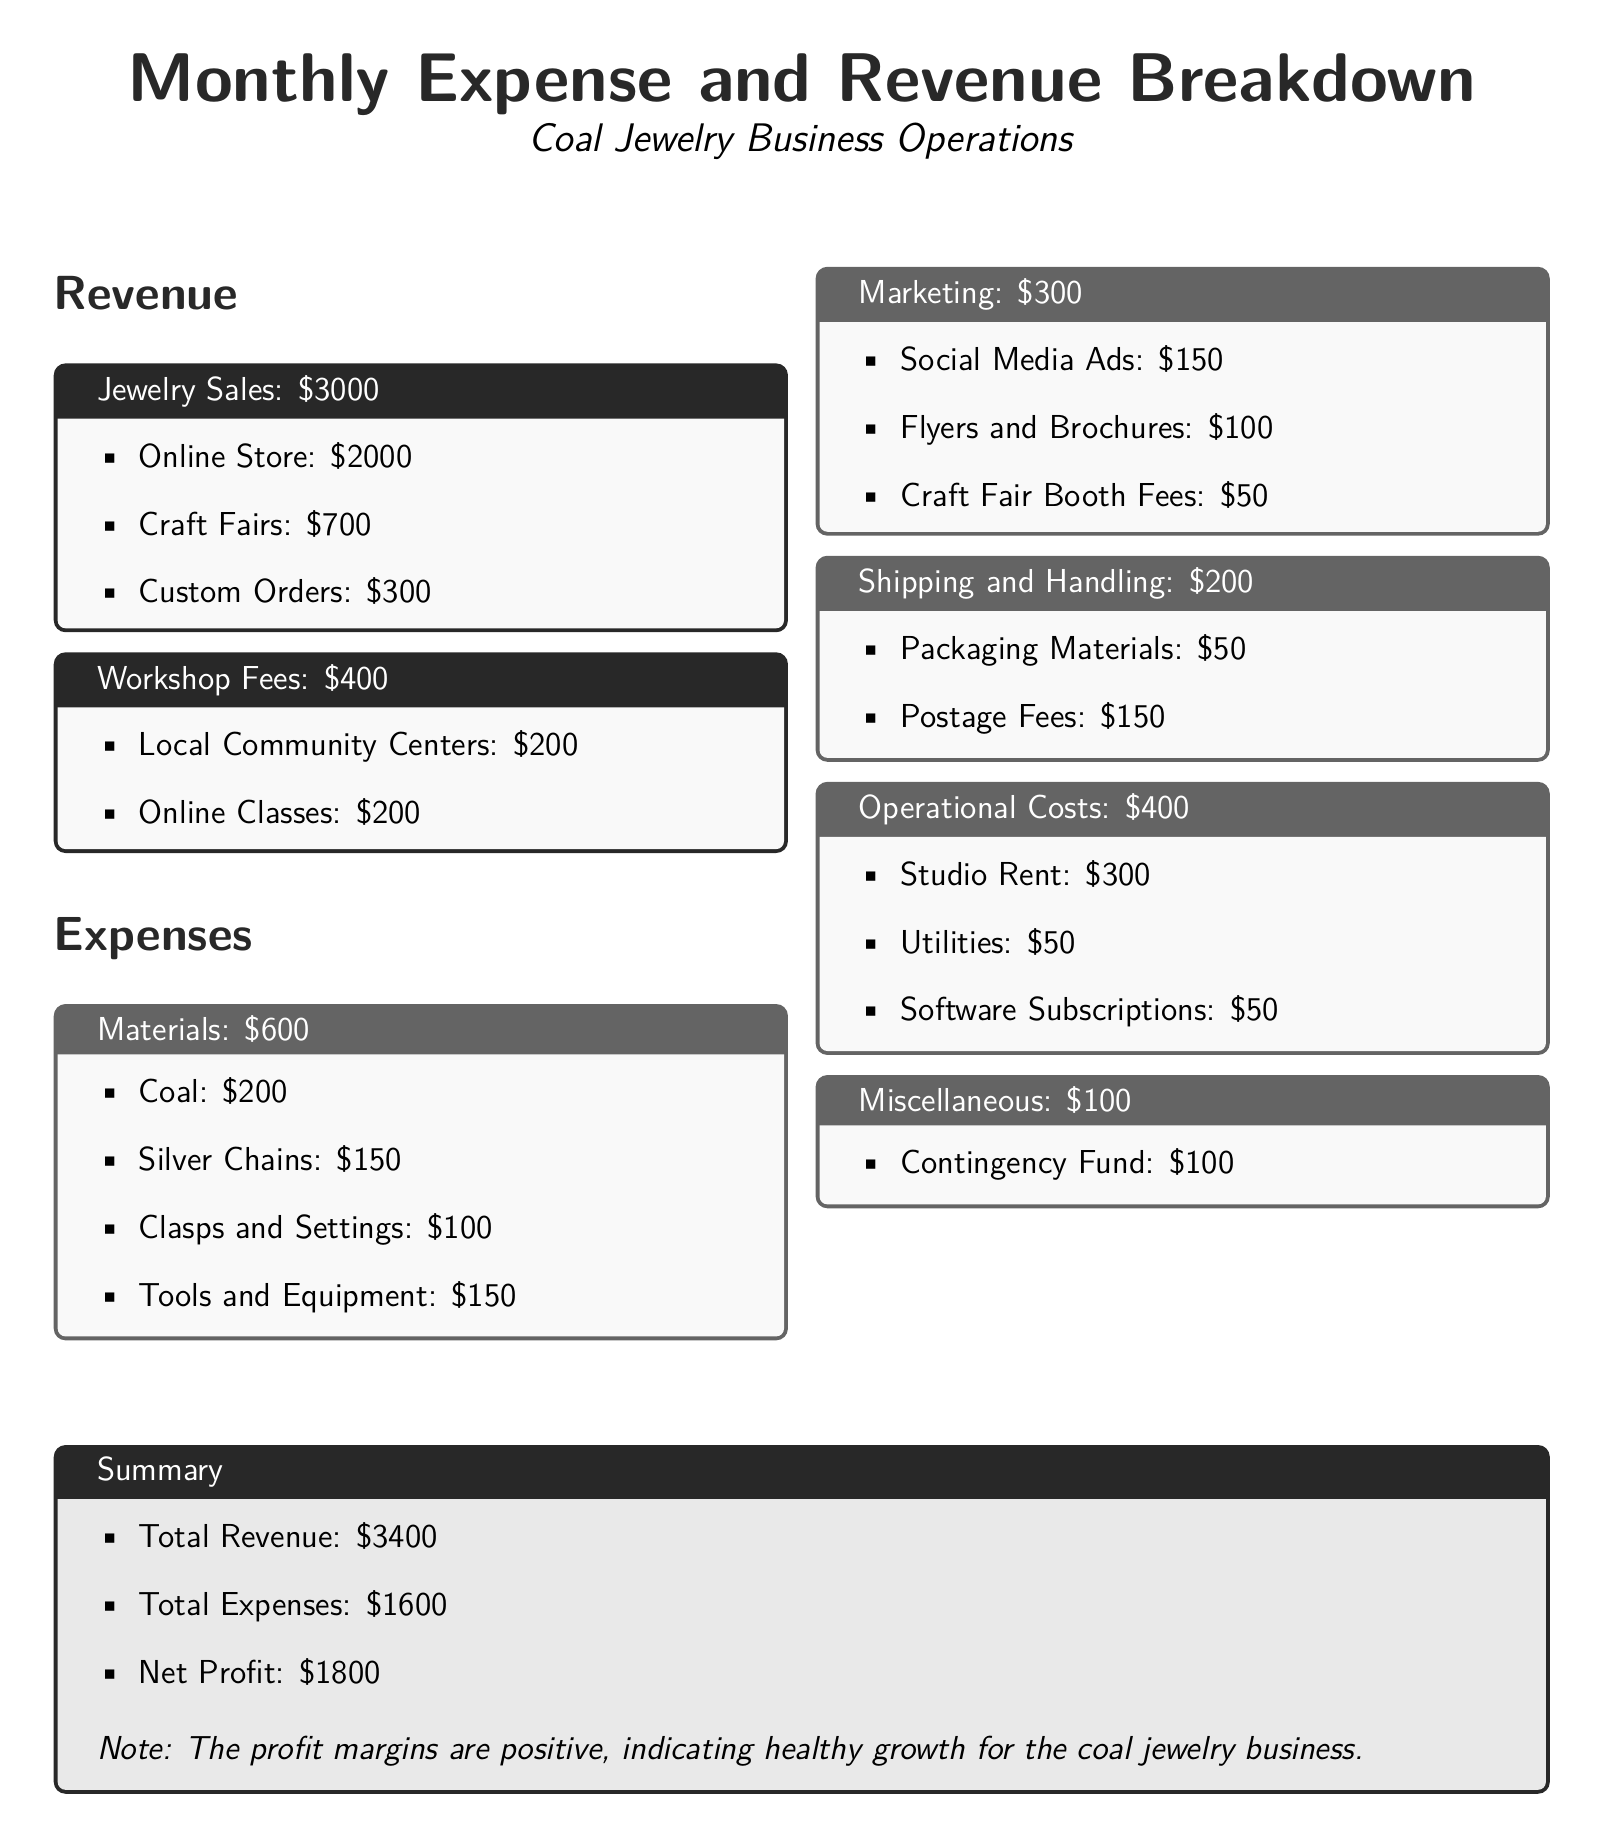What is the total revenue? The total revenue is found in the summary section of the document, which is $2000 + $700 + $300 + $400 = $3400.
Answer: $3400 What are the total expenses? The total expenses are listed in the summary section, which totals $600 + $300 + $200 + $400 + $100 = $1600.
Answer: $1600 What is the net profit? The net profit is calculated in the summary section as total revenue minus total expenses, which is $3400 - $1600 = $1800.
Answer: $1800 How much was earned from online store sales? The revenue from the online store is specifically mentioned in the revenue section, which is $2000.
Answer: $2000 What is the expense for marketing? The marketing expense total is stated in the expenses section, which is $300.
Answer: $300 What was the cost of coal materials? The cost of coal as a material is listed in the expenses section, which is $200.
Answer: $200 What types of workshops were conducted? The document specifies that workshops are conducted at local community centers and through online classes, indicating the two types offered.
Answer: Local Community Centers and Online Classes Which category has the highest expense? By comparing the expenses listed, the highest expense is found in operational costs for studio rent, which is $300.
Answer: Studio Rent How much was spent on shipping and handling? The shipping and handling expense total is provided in the expenses section as $200.
Answer: $200 What is the amount allocated for contingency fund? The contingency fund is listed under miscellaneous expenses, which states it is $100.
Answer: $100 